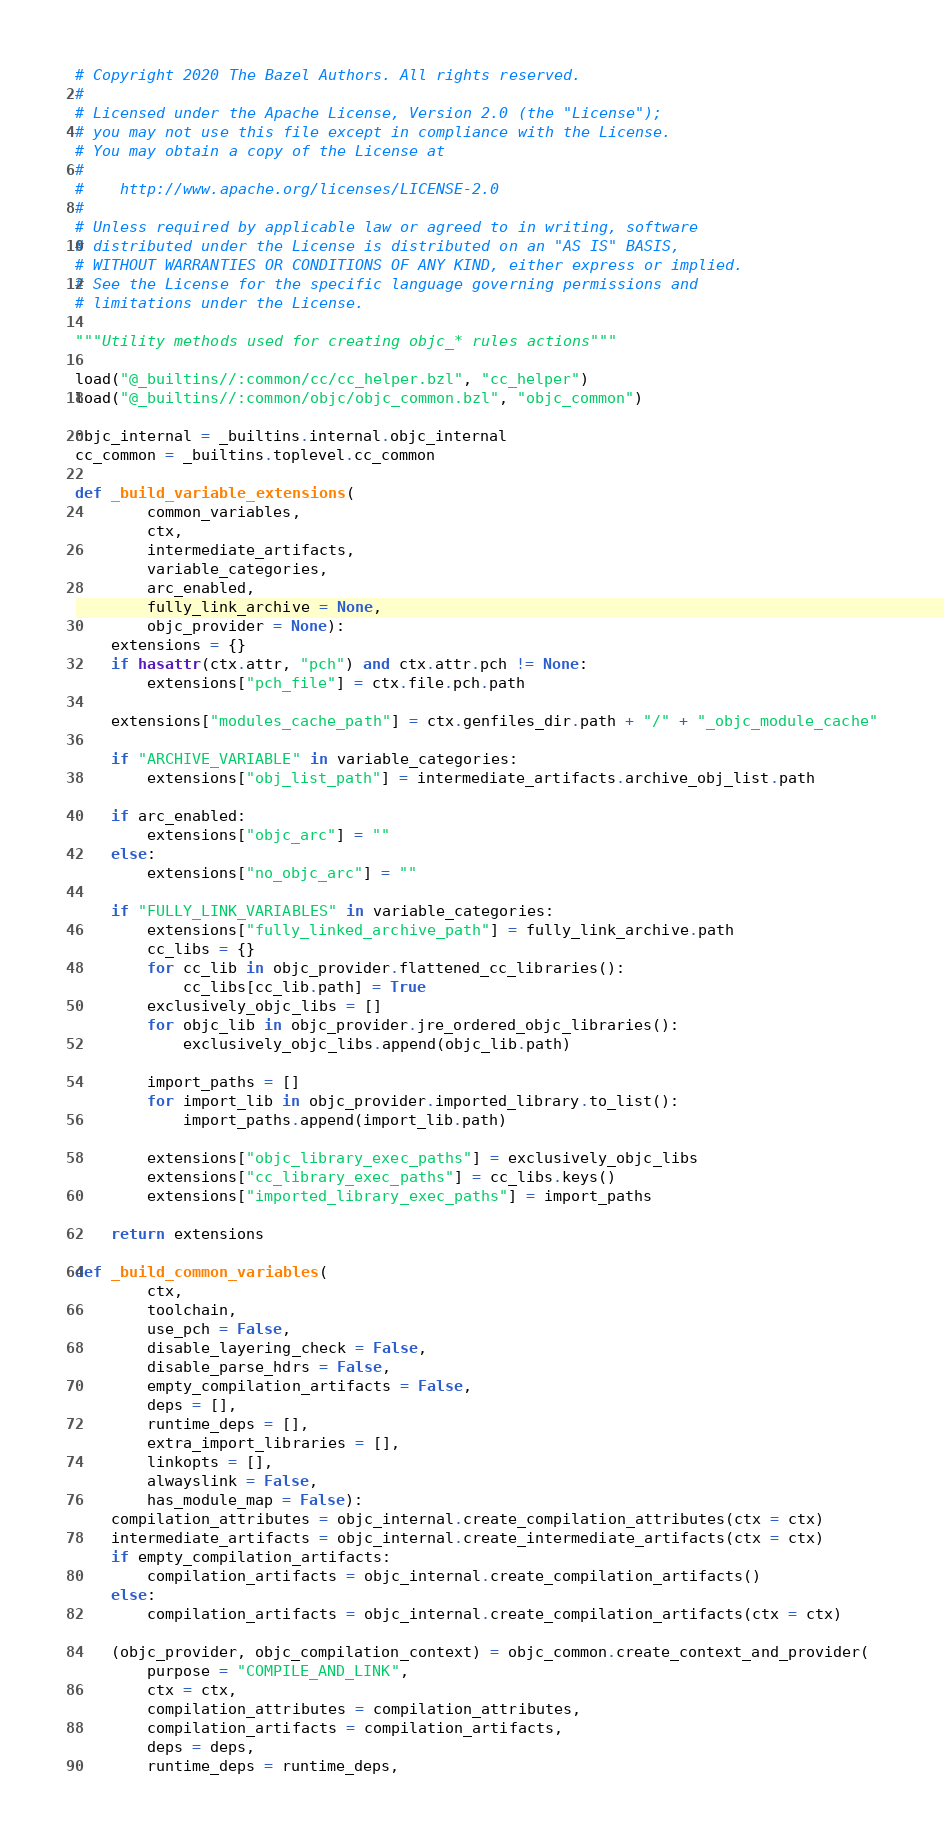<code> <loc_0><loc_0><loc_500><loc_500><_Python_># Copyright 2020 The Bazel Authors. All rights reserved.
#
# Licensed under the Apache License, Version 2.0 (the "License");
# you may not use this file except in compliance with the License.
# You may obtain a copy of the License at
#
#    http://www.apache.org/licenses/LICENSE-2.0
#
# Unless required by applicable law or agreed to in writing, software
# distributed under the License is distributed on an "AS IS" BASIS,
# WITHOUT WARRANTIES OR CONDITIONS OF ANY KIND, either express or implied.
# See the License for the specific language governing permissions and
# limitations under the License.

"""Utility methods used for creating objc_* rules actions"""

load("@_builtins//:common/cc/cc_helper.bzl", "cc_helper")
load("@_builtins//:common/objc/objc_common.bzl", "objc_common")

objc_internal = _builtins.internal.objc_internal
cc_common = _builtins.toplevel.cc_common

def _build_variable_extensions(
        common_variables,
        ctx,
        intermediate_artifacts,
        variable_categories,
        arc_enabled,
        fully_link_archive = None,
        objc_provider = None):
    extensions = {}
    if hasattr(ctx.attr, "pch") and ctx.attr.pch != None:
        extensions["pch_file"] = ctx.file.pch.path

    extensions["modules_cache_path"] = ctx.genfiles_dir.path + "/" + "_objc_module_cache"

    if "ARCHIVE_VARIABLE" in variable_categories:
        extensions["obj_list_path"] = intermediate_artifacts.archive_obj_list.path

    if arc_enabled:
        extensions["objc_arc"] = ""
    else:
        extensions["no_objc_arc"] = ""

    if "FULLY_LINK_VARIABLES" in variable_categories:
        extensions["fully_linked_archive_path"] = fully_link_archive.path
        cc_libs = {}
        for cc_lib in objc_provider.flattened_cc_libraries():
            cc_libs[cc_lib.path] = True
        exclusively_objc_libs = []
        for objc_lib in objc_provider.jre_ordered_objc_libraries():
            exclusively_objc_libs.append(objc_lib.path)

        import_paths = []
        for import_lib in objc_provider.imported_library.to_list():
            import_paths.append(import_lib.path)

        extensions["objc_library_exec_paths"] = exclusively_objc_libs
        extensions["cc_library_exec_paths"] = cc_libs.keys()
        extensions["imported_library_exec_paths"] = import_paths

    return extensions

def _build_common_variables(
        ctx,
        toolchain,
        use_pch = False,
        disable_layering_check = False,
        disable_parse_hdrs = False,
        empty_compilation_artifacts = False,
        deps = [],
        runtime_deps = [],
        extra_import_libraries = [],
        linkopts = [],
        alwayslink = False,
        has_module_map = False):
    compilation_attributes = objc_internal.create_compilation_attributes(ctx = ctx)
    intermediate_artifacts = objc_internal.create_intermediate_artifacts(ctx = ctx)
    if empty_compilation_artifacts:
        compilation_artifacts = objc_internal.create_compilation_artifacts()
    else:
        compilation_artifacts = objc_internal.create_compilation_artifacts(ctx = ctx)

    (objc_provider, objc_compilation_context) = objc_common.create_context_and_provider(
        purpose = "COMPILE_AND_LINK",
        ctx = ctx,
        compilation_attributes = compilation_attributes,
        compilation_artifacts = compilation_artifacts,
        deps = deps,
        runtime_deps = runtime_deps,</code> 